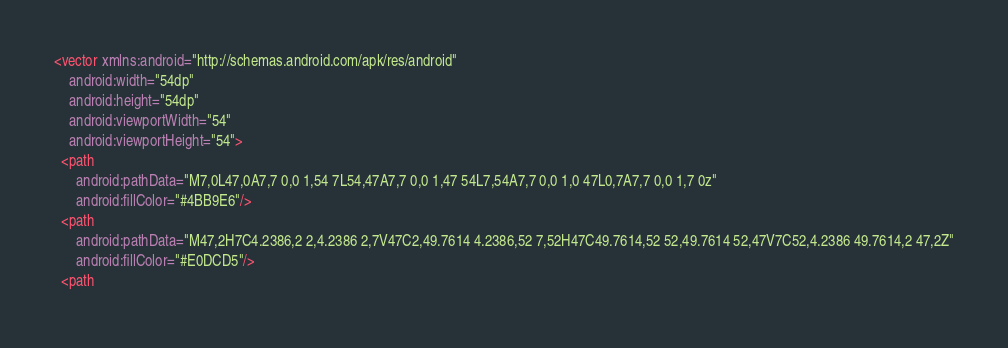<code> <loc_0><loc_0><loc_500><loc_500><_XML_><vector xmlns:android="http://schemas.android.com/apk/res/android"
    android:width="54dp"
    android:height="54dp"
    android:viewportWidth="54"
    android:viewportHeight="54">
  <path
      android:pathData="M7,0L47,0A7,7 0,0 1,54 7L54,47A7,7 0,0 1,47 54L7,54A7,7 0,0 1,0 47L0,7A7,7 0,0 1,7 0z"
      android:fillColor="#4BB9E6"/>
  <path
      android:pathData="M47,2H7C4.2386,2 2,4.2386 2,7V47C2,49.7614 4.2386,52 7,52H47C49.7614,52 52,49.7614 52,47V7C52,4.2386 49.7614,2 47,2Z"
      android:fillColor="#E0DCD5"/>
  <path</code> 